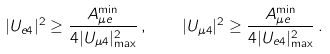Convert formula to latex. <formula><loc_0><loc_0><loc_500><loc_500>| U _ { e 4 } | ^ { 2 } \geq \frac { A _ { { \mu } e } ^ { \min } } { 4 | U _ { \mu 4 } | _ { \max } ^ { 2 } } \, , \quad | U _ { \mu 4 } | ^ { 2 } \geq \frac { A _ { { \mu } e } ^ { \min } } { 4 | U _ { e 4 } | _ { \max } ^ { 2 } } \, .</formula> 